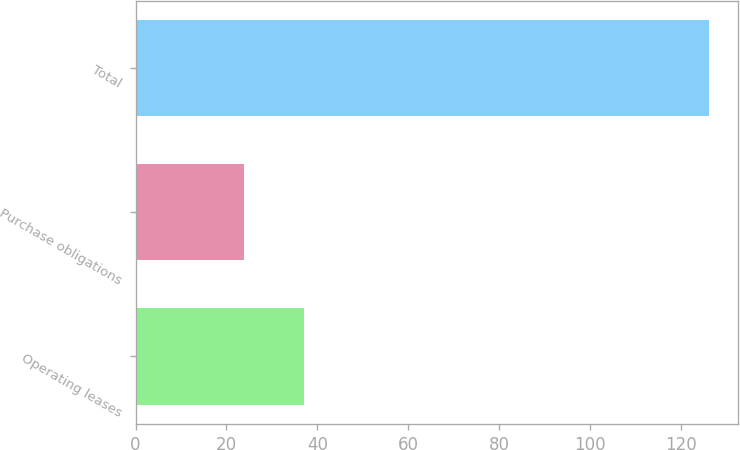Convert chart to OTSL. <chart><loc_0><loc_0><loc_500><loc_500><bar_chart><fcel>Operating leases<fcel>Purchase obligations<fcel>Total<nl><fcel>37<fcel>23.9<fcel>126.2<nl></chart> 